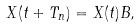Convert formula to latex. <formula><loc_0><loc_0><loc_500><loc_500>X ( t + T _ { n } ) = X ( t ) B ,</formula> 